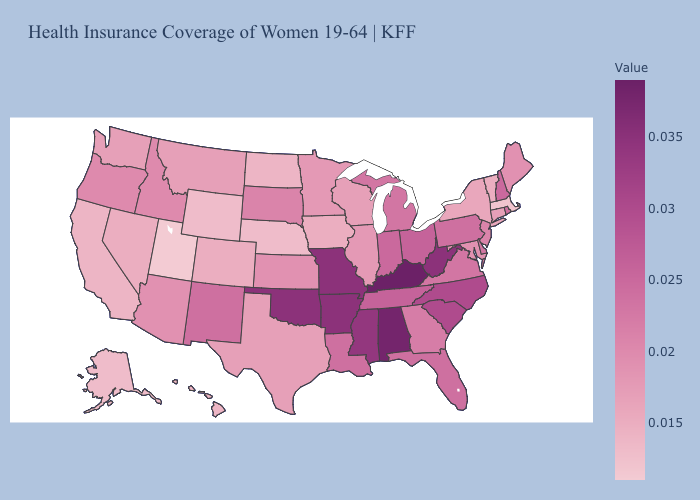Does Kansas have a lower value than New York?
Answer briefly. No. Among the states that border Connecticut , does Massachusetts have the lowest value?
Quick response, please. Yes. Among the states that border Indiana , which have the lowest value?
Keep it brief. Illinois. 